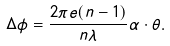<formula> <loc_0><loc_0><loc_500><loc_500>\Delta \phi = \frac { 2 \pi e ( n - 1 ) } { n \lambda } \alpha \cdot \theta .</formula> 